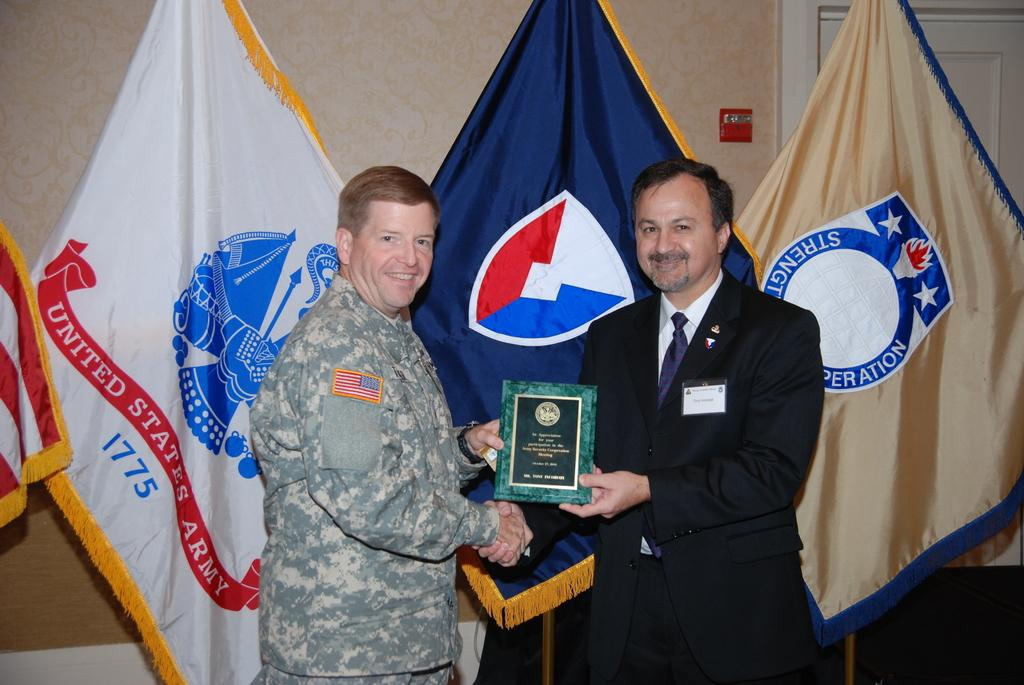Provide a one-sentence caption for the provided image. A man in a suit handing a man in a army uniform a plaque as the United States Army 1775 flag is behind. 